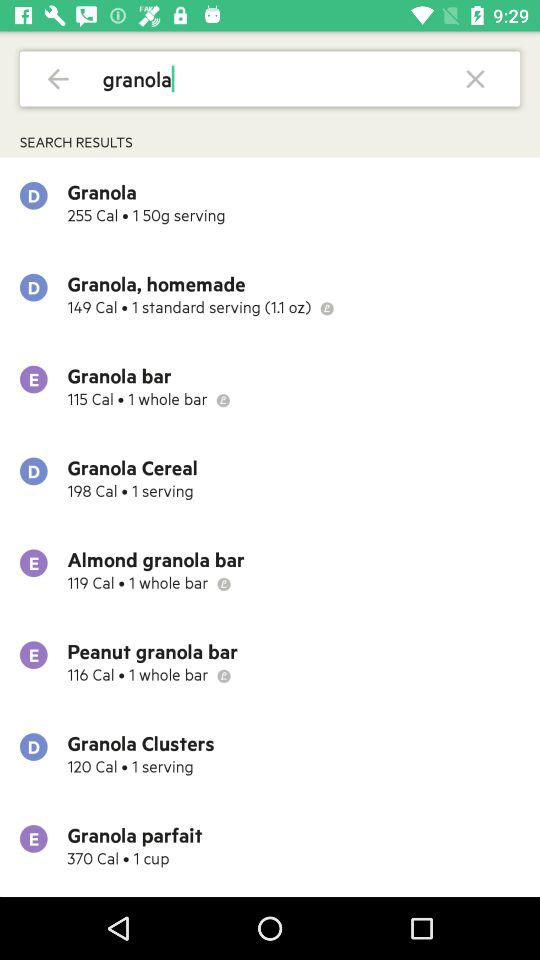What is the number of cups in the "Granola parfait"? The number of cups in the "Granola parfait" is 1. 